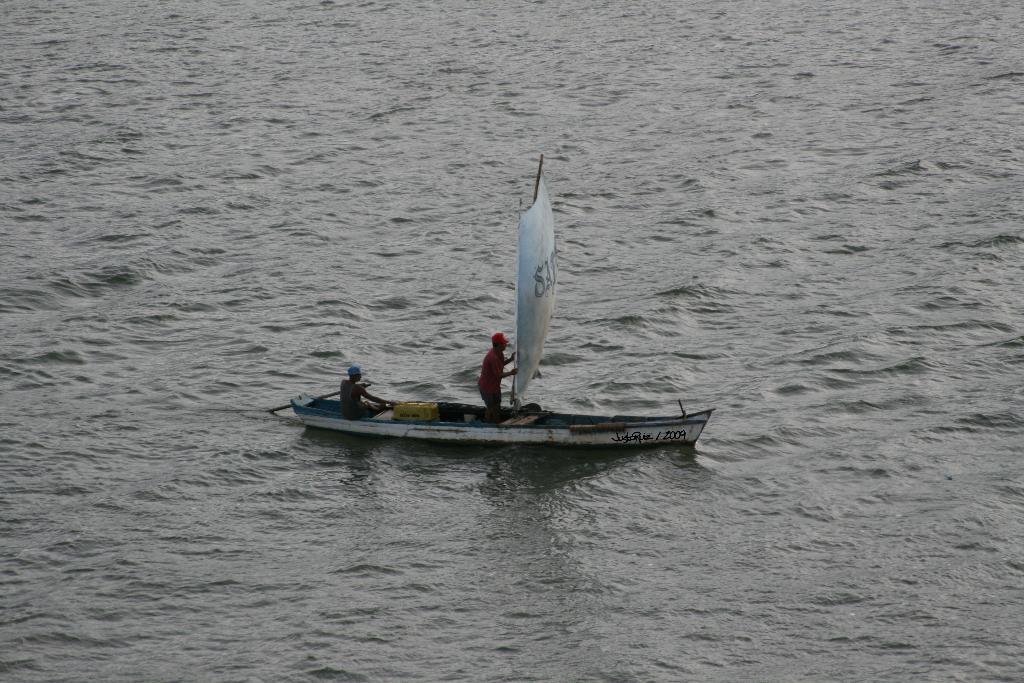Describe this image in one or two sentences. In this picture we can observe a boat, sailing on the water. We can observe a sailing cloth here. There are two members in the boat. In the background there is water. 